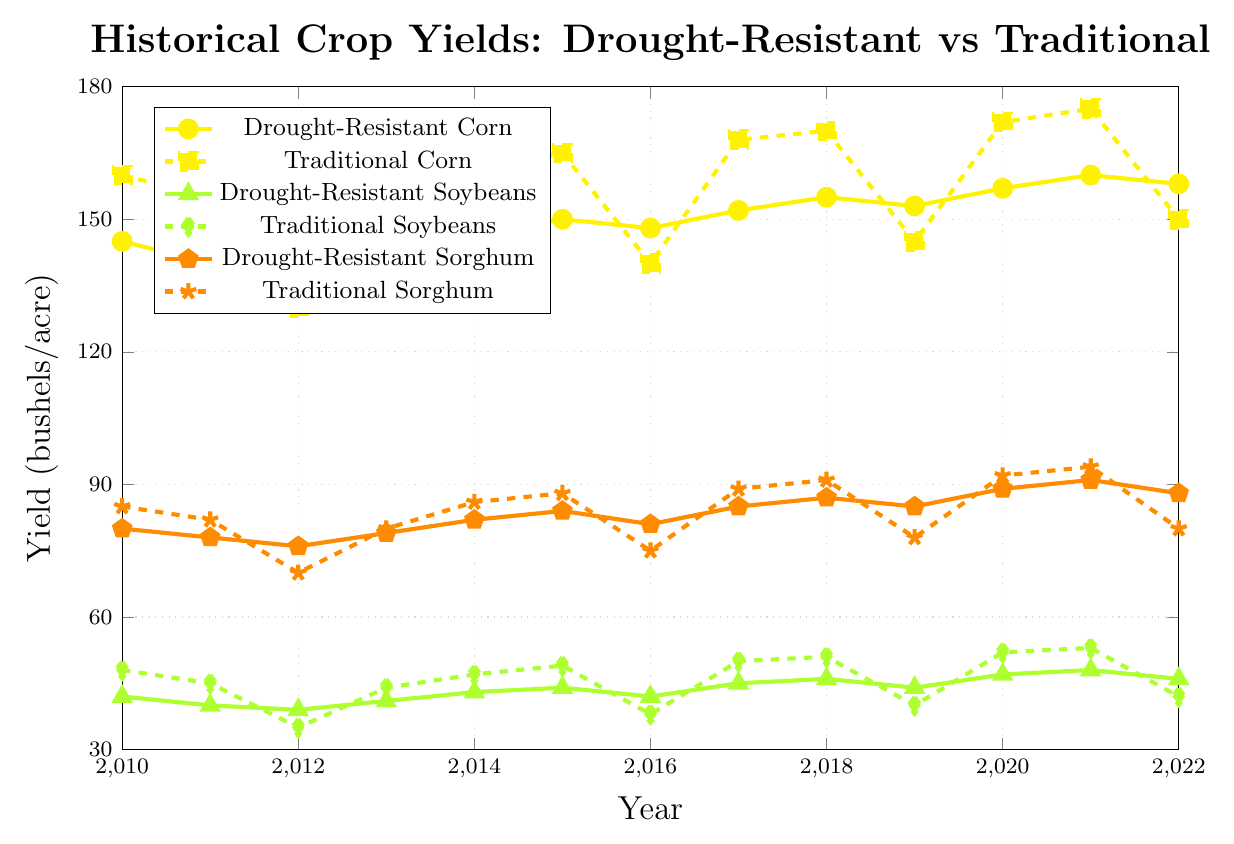Which type of corn had the highest yield in 2021? In 2021, Drought-Resistant Corn had a yield of 160 bushels/acre, while Traditional Corn had 175 bushels/acre.
Answer: Traditional Corn Between 2010 and 2022, in which year did Drought-Resistant Soybeans have your highest yield? The yields for Drought-Resistant Soybeans from 2010 to 2022 are as follows: 42, 40, 39, 41, 43, 44, 42, 45, 46, 44, 47, 48, and 46 bushels/acre. The highest yield is 48 bushels/acre in 2021.
Answer: 2021 Compare the yields of Traditional Sorghum in 2019 and 2022, which year had a lower yield and by how much? Traditional Sorghum had a yield of 78 bushels/acre in 2019 and 80 bushels/acre in 2022. The yield in 2019 was lower by 2 bushels/acre.
Answer: 2019, by 2 bushels/acre What was the average yield of Drought-Resistant Sorghum from 2010 to 2022? The yields for Drought-Resistant Sorghum from 2010 to 2022 are: 80, 78, 76, 79, 82, 84, 81, 85, 87, 85, 89, 91, and 88 bushels/acre. Sum these to get 1085, and divide by 13 (number of years): 1085 / 13 ≈ 83.46 bushels/acre.
Answer: 83.46 bushels/acre Which crop type had the largest drop in yield between 2011 and 2012? Comparing the yields from 2011 to 2012: Drought-Resistant Corn decreased by 2 (140 to 138), Traditional Corn decreased by 25 (155 to 130), Drought-Resistant Soybeans decreased by 1 (40 to 39), Traditional Soybeans decreased by 10 (45 to 35), Drought-Resistant Sorghum decreased by 2 (78 to 76), Traditional Sorghum decreased by 12 (82 to 70). The largest drop is for Traditional Corn.
Answer: Traditional Corn In which year did Traditional Corn have a lower yield than Drought-Resistant Corn? Comparing the yields each year, Traditional Corn had a lower yield in 2012 (130 vs 138) and 2016 (140 vs 148).
Answer: 2012 and 2016 What was the total yield difference between Drought-Resistant and Traditional Soybeans in 2018? Drought-Resistant Soybeans had a yield of 46 bushels/acre, while Traditional Soybeans had a yield of 51 bushels/acre. The difference is 51 - 46 = 5 bushels/acre.
Answer: 5 bushels/acre Over the entire period, which crop type consistently had higher yields, Drought-Resistant Sorghum or Traditional Sorghum? By observing the yearly yields for Drought-Resistant Sorghum and Traditional Sorghum, we see that except for 2012 (76 vs 70) and 2019 (85 vs 78), Traditional Sorghum consistently had higher yields.
Answer: Traditional Sorghum What was the lowest yield recorded among all the crop types and in which year? The lowest yield recorded is 35 bushels/acre by Traditional Soybeans in 2012.
Answer: 35 bushels/acre in 2012 How does the yield trend of Drought-Resistant Corn compare with Traditional Corn from 2012 to 2022? From 2012 to 2022, both Drought-Resistant Corn and Traditional Corn show an overall increasing trend, although Traditional Corn has more fluctuations. Drought-Resistant Corn increased from 138 to 158 bushels/acre, while Traditional Corn increased from 130 to 150 bushels/acre.
Answer: Both increased but Traditional more fluctuating 